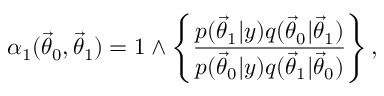Convert formula to latex. <formula><loc_0><loc_0><loc_500><loc_500>\alpha _ { 1 } ( { \vec { \theta } } _ { 0 } , { \vec { \theta } } _ { 1 } ) = 1 \wedge \left \{ \frac { p ( { \vec { \theta } } _ { 1 } | y ) q ( { \vec { \theta } } _ { 0 } | { \vec { \theta } } _ { 1 } ) } { p ( { \vec { \theta } } _ { 0 } | y ) q ( { \vec { \theta } } _ { 1 } | { \vec { \theta } } _ { 0 } ) } \right \} ,</formula> 